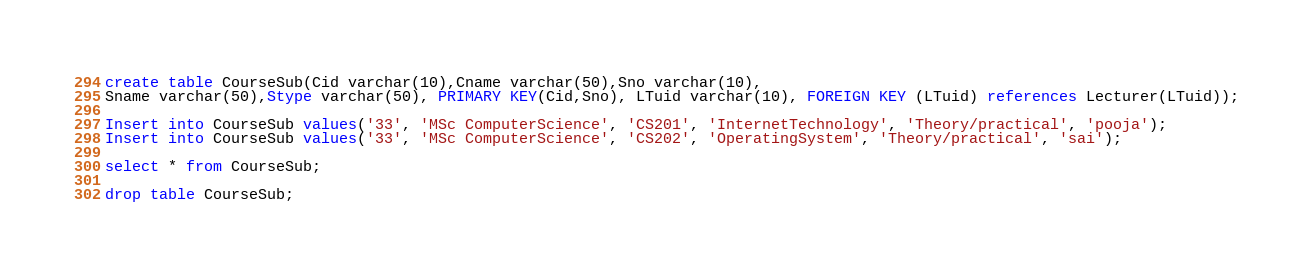<code> <loc_0><loc_0><loc_500><loc_500><_SQL_>
create table CourseSub(Cid varchar(10),Cname varchar(50),Sno varchar(10),
Sname varchar(50),Stype varchar(50), PRIMARY KEY(Cid,Sno), LTuid varchar(10), FOREIGN KEY (LTuid) references Lecturer(LTuid));

Insert into CourseSub values('33', 'MSc ComputerScience', 'CS201', 'InternetTechnology', 'Theory/practical', 'pooja');
Insert into CourseSub values('33', 'MSc ComputerScience', 'CS202', 'OperatingSystem', 'Theory/practical', 'sai');

select * from CourseSub;

drop table CourseSub;</code> 